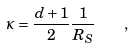Convert formula to latex. <formula><loc_0><loc_0><loc_500><loc_500>\kappa = \frac { d + 1 } { 2 } \frac { 1 } { R _ { S } } \quad ,</formula> 